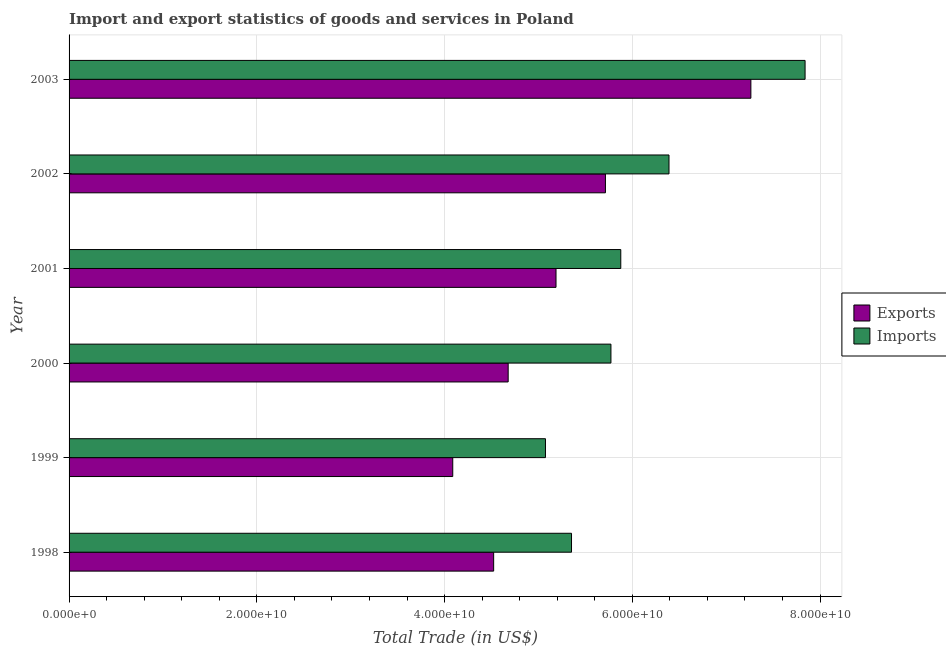How many groups of bars are there?
Your answer should be compact. 6. Are the number of bars per tick equal to the number of legend labels?
Provide a short and direct response. Yes. How many bars are there on the 1st tick from the top?
Your answer should be very brief. 2. How many bars are there on the 2nd tick from the bottom?
Offer a very short reply. 2. In how many cases, is the number of bars for a given year not equal to the number of legend labels?
Give a very brief answer. 0. What is the imports of goods and services in 1998?
Your answer should be compact. 5.35e+1. Across all years, what is the maximum export of goods and services?
Make the answer very short. 7.26e+1. Across all years, what is the minimum imports of goods and services?
Provide a succinct answer. 5.07e+1. In which year was the export of goods and services maximum?
Give a very brief answer. 2003. In which year was the export of goods and services minimum?
Your response must be concise. 1999. What is the total export of goods and services in the graph?
Ensure brevity in your answer.  3.15e+11. What is the difference between the imports of goods and services in 1998 and that in 2001?
Your answer should be very brief. -5.25e+09. What is the difference between the imports of goods and services in 2000 and the export of goods and services in 2003?
Provide a succinct answer. -1.49e+1. What is the average export of goods and services per year?
Ensure brevity in your answer.  5.24e+1. In the year 2000, what is the difference between the export of goods and services and imports of goods and services?
Your response must be concise. -1.09e+1. In how many years, is the imports of goods and services greater than 16000000000 US$?
Offer a very short reply. 6. What is the ratio of the export of goods and services in 1999 to that in 2003?
Ensure brevity in your answer.  0.56. What is the difference between the highest and the second highest export of goods and services?
Your answer should be compact. 1.55e+1. What is the difference between the highest and the lowest imports of goods and services?
Keep it short and to the point. 2.77e+1. Is the sum of the imports of goods and services in 1998 and 2002 greater than the maximum export of goods and services across all years?
Your answer should be very brief. Yes. What does the 2nd bar from the top in 2000 represents?
Your answer should be compact. Exports. What does the 2nd bar from the bottom in 2000 represents?
Make the answer very short. Imports. Are all the bars in the graph horizontal?
Your answer should be very brief. Yes. Are the values on the major ticks of X-axis written in scientific E-notation?
Make the answer very short. Yes. Does the graph contain grids?
Your response must be concise. Yes. What is the title of the graph?
Give a very brief answer. Import and export statistics of goods and services in Poland. What is the label or title of the X-axis?
Keep it short and to the point. Total Trade (in US$). What is the Total Trade (in US$) of Exports in 1998?
Offer a terse response. 4.52e+1. What is the Total Trade (in US$) of Imports in 1998?
Offer a very short reply. 5.35e+1. What is the Total Trade (in US$) of Exports in 1999?
Your answer should be compact. 4.09e+1. What is the Total Trade (in US$) in Imports in 1999?
Keep it short and to the point. 5.07e+1. What is the Total Trade (in US$) in Exports in 2000?
Keep it short and to the point. 4.68e+1. What is the Total Trade (in US$) in Imports in 2000?
Provide a succinct answer. 5.77e+1. What is the Total Trade (in US$) of Exports in 2001?
Your response must be concise. 5.19e+1. What is the Total Trade (in US$) of Imports in 2001?
Provide a short and direct response. 5.88e+1. What is the Total Trade (in US$) in Exports in 2002?
Offer a very short reply. 5.71e+1. What is the Total Trade (in US$) in Imports in 2002?
Offer a very short reply. 6.39e+1. What is the Total Trade (in US$) in Exports in 2003?
Your answer should be very brief. 7.26e+1. What is the Total Trade (in US$) in Imports in 2003?
Provide a succinct answer. 7.84e+1. Across all years, what is the maximum Total Trade (in US$) of Exports?
Your answer should be compact. 7.26e+1. Across all years, what is the maximum Total Trade (in US$) in Imports?
Give a very brief answer. 7.84e+1. Across all years, what is the minimum Total Trade (in US$) in Exports?
Offer a very short reply. 4.09e+1. Across all years, what is the minimum Total Trade (in US$) in Imports?
Your response must be concise. 5.07e+1. What is the total Total Trade (in US$) in Exports in the graph?
Give a very brief answer. 3.15e+11. What is the total Total Trade (in US$) of Imports in the graph?
Make the answer very short. 3.63e+11. What is the difference between the Total Trade (in US$) in Exports in 1998 and that in 1999?
Provide a short and direct response. 4.36e+09. What is the difference between the Total Trade (in US$) in Imports in 1998 and that in 1999?
Ensure brevity in your answer.  2.77e+09. What is the difference between the Total Trade (in US$) of Exports in 1998 and that in 2000?
Offer a very short reply. -1.55e+09. What is the difference between the Total Trade (in US$) in Imports in 1998 and that in 2000?
Your response must be concise. -4.20e+09. What is the difference between the Total Trade (in US$) in Exports in 1998 and that in 2001?
Your answer should be very brief. -6.64e+09. What is the difference between the Total Trade (in US$) of Imports in 1998 and that in 2001?
Make the answer very short. -5.25e+09. What is the difference between the Total Trade (in US$) in Exports in 1998 and that in 2002?
Your answer should be very brief. -1.19e+1. What is the difference between the Total Trade (in US$) of Imports in 1998 and that in 2002?
Provide a succinct answer. -1.04e+1. What is the difference between the Total Trade (in US$) of Exports in 1998 and that in 2003?
Give a very brief answer. -2.74e+1. What is the difference between the Total Trade (in US$) in Imports in 1998 and that in 2003?
Your answer should be very brief. -2.49e+1. What is the difference between the Total Trade (in US$) of Exports in 1999 and that in 2000?
Your response must be concise. -5.90e+09. What is the difference between the Total Trade (in US$) of Imports in 1999 and that in 2000?
Ensure brevity in your answer.  -6.97e+09. What is the difference between the Total Trade (in US$) of Exports in 1999 and that in 2001?
Make the answer very short. -1.10e+1. What is the difference between the Total Trade (in US$) of Imports in 1999 and that in 2001?
Your answer should be very brief. -8.02e+09. What is the difference between the Total Trade (in US$) of Exports in 1999 and that in 2002?
Your answer should be very brief. -1.63e+1. What is the difference between the Total Trade (in US$) in Imports in 1999 and that in 2002?
Your answer should be very brief. -1.32e+1. What is the difference between the Total Trade (in US$) of Exports in 1999 and that in 2003?
Your response must be concise. -3.18e+1. What is the difference between the Total Trade (in US$) in Imports in 1999 and that in 2003?
Make the answer very short. -2.77e+1. What is the difference between the Total Trade (in US$) in Exports in 2000 and that in 2001?
Offer a very short reply. -5.10e+09. What is the difference between the Total Trade (in US$) in Imports in 2000 and that in 2001?
Your answer should be very brief. -1.05e+09. What is the difference between the Total Trade (in US$) of Exports in 2000 and that in 2002?
Your response must be concise. -1.04e+1. What is the difference between the Total Trade (in US$) in Imports in 2000 and that in 2002?
Your answer should be compact. -6.18e+09. What is the difference between the Total Trade (in US$) in Exports in 2000 and that in 2003?
Provide a succinct answer. -2.59e+1. What is the difference between the Total Trade (in US$) in Imports in 2000 and that in 2003?
Offer a terse response. -2.07e+1. What is the difference between the Total Trade (in US$) in Exports in 2001 and that in 2002?
Offer a terse response. -5.26e+09. What is the difference between the Total Trade (in US$) of Imports in 2001 and that in 2002?
Give a very brief answer. -5.14e+09. What is the difference between the Total Trade (in US$) of Exports in 2001 and that in 2003?
Your answer should be compact. -2.08e+1. What is the difference between the Total Trade (in US$) of Imports in 2001 and that in 2003?
Keep it short and to the point. -1.96e+1. What is the difference between the Total Trade (in US$) of Exports in 2002 and that in 2003?
Offer a terse response. -1.55e+1. What is the difference between the Total Trade (in US$) of Imports in 2002 and that in 2003?
Make the answer very short. -1.45e+1. What is the difference between the Total Trade (in US$) of Exports in 1998 and the Total Trade (in US$) of Imports in 1999?
Keep it short and to the point. -5.52e+09. What is the difference between the Total Trade (in US$) in Exports in 1998 and the Total Trade (in US$) in Imports in 2000?
Provide a short and direct response. -1.25e+1. What is the difference between the Total Trade (in US$) in Exports in 1998 and the Total Trade (in US$) in Imports in 2001?
Your response must be concise. -1.35e+1. What is the difference between the Total Trade (in US$) in Exports in 1998 and the Total Trade (in US$) in Imports in 2002?
Keep it short and to the point. -1.87e+1. What is the difference between the Total Trade (in US$) of Exports in 1998 and the Total Trade (in US$) of Imports in 2003?
Make the answer very short. -3.32e+1. What is the difference between the Total Trade (in US$) in Exports in 1999 and the Total Trade (in US$) in Imports in 2000?
Provide a succinct answer. -1.69e+1. What is the difference between the Total Trade (in US$) of Exports in 1999 and the Total Trade (in US$) of Imports in 2001?
Provide a short and direct response. -1.79e+1. What is the difference between the Total Trade (in US$) in Exports in 1999 and the Total Trade (in US$) in Imports in 2002?
Offer a terse response. -2.30e+1. What is the difference between the Total Trade (in US$) in Exports in 1999 and the Total Trade (in US$) in Imports in 2003?
Give a very brief answer. -3.75e+1. What is the difference between the Total Trade (in US$) of Exports in 2000 and the Total Trade (in US$) of Imports in 2001?
Provide a succinct answer. -1.20e+1. What is the difference between the Total Trade (in US$) of Exports in 2000 and the Total Trade (in US$) of Imports in 2002?
Offer a very short reply. -1.71e+1. What is the difference between the Total Trade (in US$) of Exports in 2000 and the Total Trade (in US$) of Imports in 2003?
Your response must be concise. -3.16e+1. What is the difference between the Total Trade (in US$) in Exports in 2001 and the Total Trade (in US$) in Imports in 2002?
Offer a very short reply. -1.20e+1. What is the difference between the Total Trade (in US$) of Exports in 2001 and the Total Trade (in US$) of Imports in 2003?
Provide a short and direct response. -2.65e+1. What is the difference between the Total Trade (in US$) in Exports in 2002 and the Total Trade (in US$) in Imports in 2003?
Your answer should be compact. -2.13e+1. What is the average Total Trade (in US$) of Exports per year?
Your answer should be compact. 5.24e+1. What is the average Total Trade (in US$) in Imports per year?
Offer a terse response. 6.05e+1. In the year 1998, what is the difference between the Total Trade (in US$) in Exports and Total Trade (in US$) in Imports?
Your answer should be compact. -8.29e+09. In the year 1999, what is the difference between the Total Trade (in US$) of Exports and Total Trade (in US$) of Imports?
Provide a succinct answer. -9.88e+09. In the year 2000, what is the difference between the Total Trade (in US$) of Exports and Total Trade (in US$) of Imports?
Your response must be concise. -1.09e+1. In the year 2001, what is the difference between the Total Trade (in US$) in Exports and Total Trade (in US$) in Imports?
Make the answer very short. -6.90e+09. In the year 2002, what is the difference between the Total Trade (in US$) of Exports and Total Trade (in US$) of Imports?
Make the answer very short. -6.77e+09. In the year 2003, what is the difference between the Total Trade (in US$) in Exports and Total Trade (in US$) in Imports?
Ensure brevity in your answer.  -5.77e+09. What is the ratio of the Total Trade (in US$) in Exports in 1998 to that in 1999?
Provide a succinct answer. 1.11. What is the ratio of the Total Trade (in US$) of Imports in 1998 to that in 1999?
Provide a short and direct response. 1.05. What is the ratio of the Total Trade (in US$) in Imports in 1998 to that in 2000?
Make the answer very short. 0.93. What is the ratio of the Total Trade (in US$) in Exports in 1998 to that in 2001?
Your answer should be compact. 0.87. What is the ratio of the Total Trade (in US$) in Imports in 1998 to that in 2001?
Give a very brief answer. 0.91. What is the ratio of the Total Trade (in US$) in Exports in 1998 to that in 2002?
Your answer should be compact. 0.79. What is the ratio of the Total Trade (in US$) in Imports in 1998 to that in 2002?
Ensure brevity in your answer.  0.84. What is the ratio of the Total Trade (in US$) in Exports in 1998 to that in 2003?
Keep it short and to the point. 0.62. What is the ratio of the Total Trade (in US$) of Imports in 1998 to that in 2003?
Keep it short and to the point. 0.68. What is the ratio of the Total Trade (in US$) in Exports in 1999 to that in 2000?
Your answer should be very brief. 0.87. What is the ratio of the Total Trade (in US$) of Imports in 1999 to that in 2000?
Offer a very short reply. 0.88. What is the ratio of the Total Trade (in US$) of Exports in 1999 to that in 2001?
Give a very brief answer. 0.79. What is the ratio of the Total Trade (in US$) of Imports in 1999 to that in 2001?
Provide a short and direct response. 0.86. What is the ratio of the Total Trade (in US$) of Exports in 1999 to that in 2002?
Offer a very short reply. 0.72. What is the ratio of the Total Trade (in US$) in Imports in 1999 to that in 2002?
Your response must be concise. 0.79. What is the ratio of the Total Trade (in US$) in Exports in 1999 to that in 2003?
Provide a short and direct response. 0.56. What is the ratio of the Total Trade (in US$) in Imports in 1999 to that in 2003?
Your answer should be compact. 0.65. What is the ratio of the Total Trade (in US$) in Exports in 2000 to that in 2001?
Your answer should be compact. 0.9. What is the ratio of the Total Trade (in US$) of Imports in 2000 to that in 2001?
Ensure brevity in your answer.  0.98. What is the ratio of the Total Trade (in US$) of Exports in 2000 to that in 2002?
Provide a short and direct response. 0.82. What is the ratio of the Total Trade (in US$) of Imports in 2000 to that in 2002?
Give a very brief answer. 0.9. What is the ratio of the Total Trade (in US$) in Exports in 2000 to that in 2003?
Keep it short and to the point. 0.64. What is the ratio of the Total Trade (in US$) in Imports in 2000 to that in 2003?
Offer a terse response. 0.74. What is the ratio of the Total Trade (in US$) of Exports in 2001 to that in 2002?
Offer a very short reply. 0.91. What is the ratio of the Total Trade (in US$) in Imports in 2001 to that in 2002?
Your answer should be compact. 0.92. What is the ratio of the Total Trade (in US$) of Exports in 2001 to that in 2003?
Offer a very short reply. 0.71. What is the ratio of the Total Trade (in US$) of Imports in 2001 to that in 2003?
Keep it short and to the point. 0.75. What is the ratio of the Total Trade (in US$) of Exports in 2002 to that in 2003?
Make the answer very short. 0.79. What is the ratio of the Total Trade (in US$) of Imports in 2002 to that in 2003?
Give a very brief answer. 0.82. What is the difference between the highest and the second highest Total Trade (in US$) in Exports?
Your response must be concise. 1.55e+1. What is the difference between the highest and the second highest Total Trade (in US$) of Imports?
Your response must be concise. 1.45e+1. What is the difference between the highest and the lowest Total Trade (in US$) of Exports?
Your answer should be very brief. 3.18e+1. What is the difference between the highest and the lowest Total Trade (in US$) in Imports?
Your answer should be very brief. 2.77e+1. 